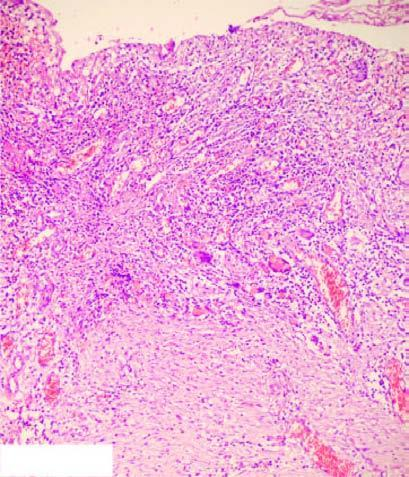does ideroblastic anaemia bone marrow show necrotic debris, ulceration and inflammation on the mucosal surface?
Answer the question using a single word or phrase. No 